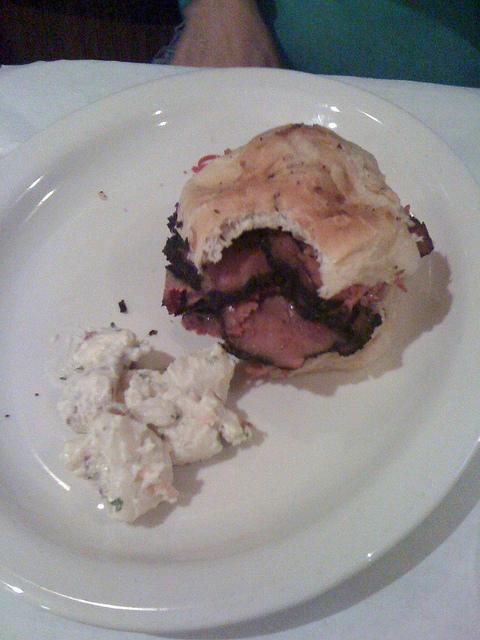What is the side dish?
Select the correct answer and articulate reasoning with the following format: 'Answer: answer
Rationale: rationale.'
Options: Potato salad, beets, carrots, fries. Answer: potato salad.
Rationale: It is chunks of potato with a creamy dressing 